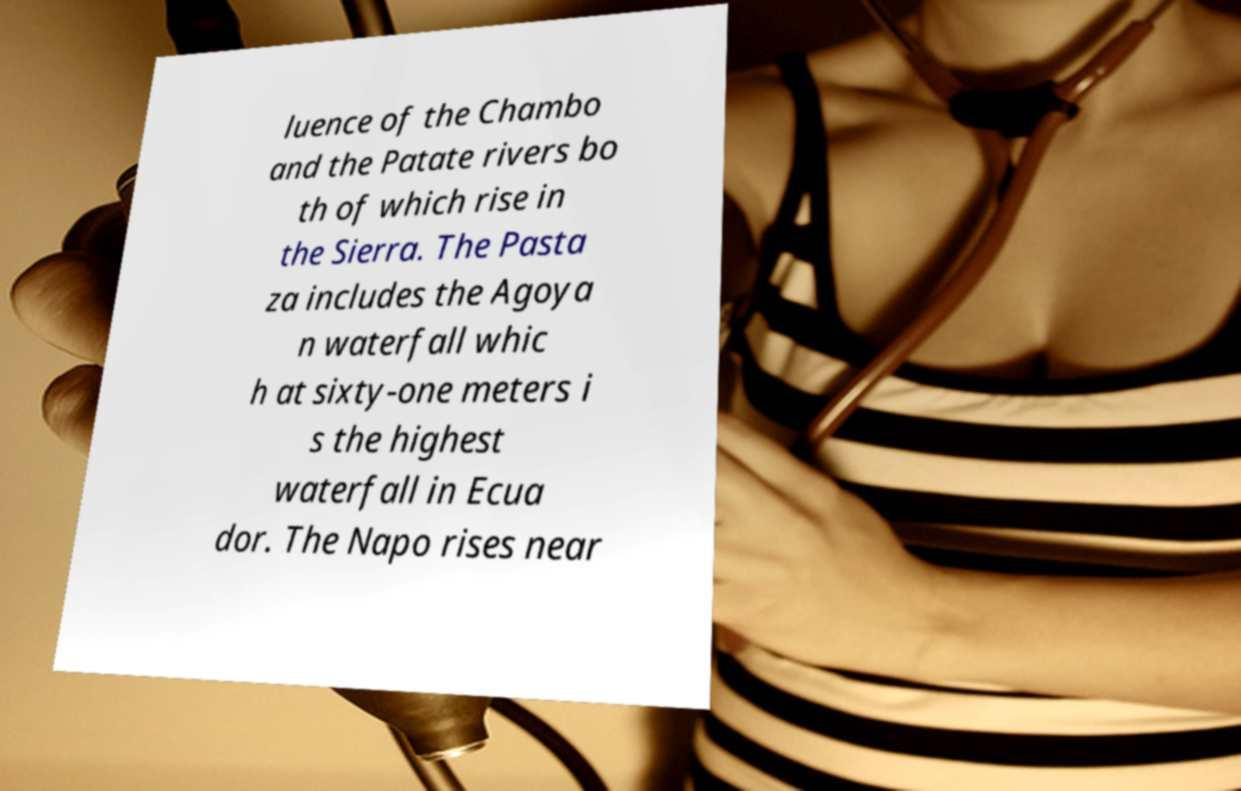Please read and relay the text visible in this image. What does it say? luence of the Chambo and the Patate rivers bo th of which rise in the Sierra. The Pasta za includes the Agoya n waterfall whic h at sixty-one meters i s the highest waterfall in Ecua dor. The Napo rises near 